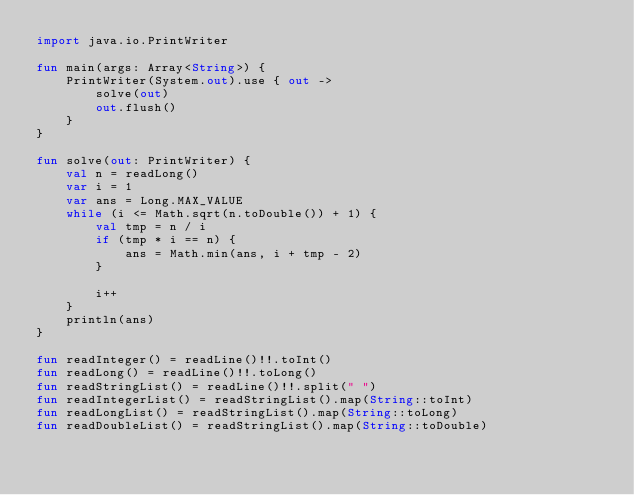<code> <loc_0><loc_0><loc_500><loc_500><_Kotlin_>import java.io.PrintWriter

fun main(args: Array<String>) {
    PrintWriter(System.out).use { out ->
        solve(out)
        out.flush()
    }
}

fun solve(out: PrintWriter) {
    val n = readLong()
    var i = 1
    var ans = Long.MAX_VALUE
    while (i <= Math.sqrt(n.toDouble()) + 1) {
        val tmp = n / i
        if (tmp * i == n) {
            ans = Math.min(ans, i + tmp - 2)
        }

        i++
    }
    println(ans)
}

fun readInteger() = readLine()!!.toInt()
fun readLong() = readLine()!!.toLong()
fun readStringList() = readLine()!!.split(" ")
fun readIntegerList() = readStringList().map(String::toInt)
fun readLongList() = readStringList().map(String::toLong)
fun readDoubleList() = readStringList().map(String::toDouble)
</code> 